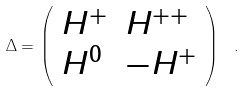<formula> <loc_0><loc_0><loc_500><loc_500>\Delta = \left ( \begin{array} { l l } { { H ^ { + } } } & { { H ^ { + + } } } \\ { { H ^ { 0 } } } & { { - H ^ { + } } } \end{array} \right ) \ .</formula> 